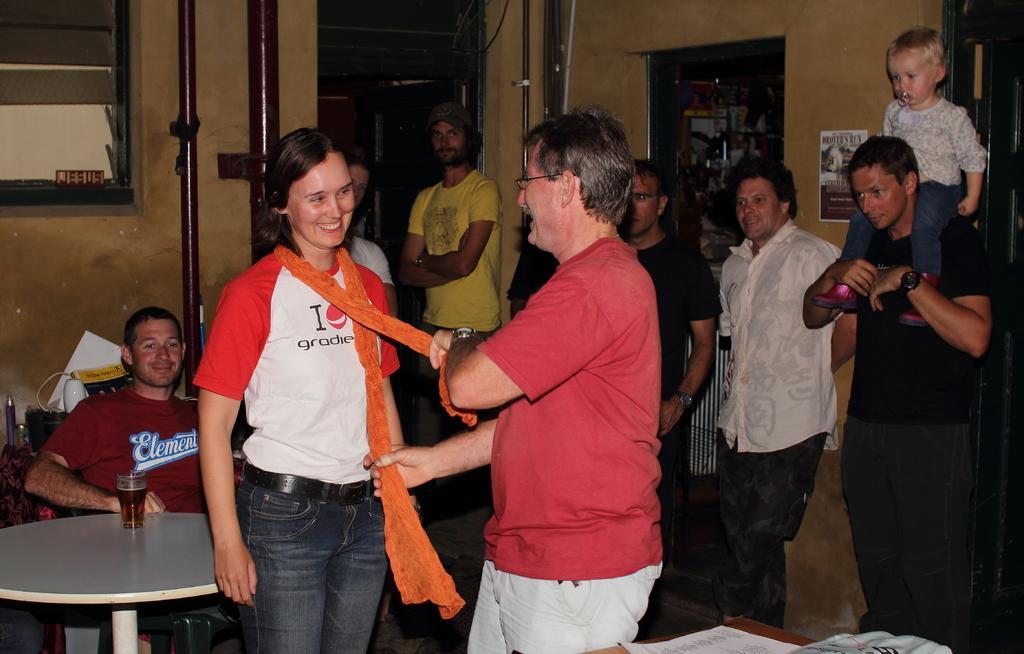Please provide a concise description of this image. In this image we can see people standing on the floor and some are sitting on the chairs. In addition to this we can see a glass tumbler with beverage in it, metal rods, side table, papers pasted on the wall and polythene cover on the wall. 